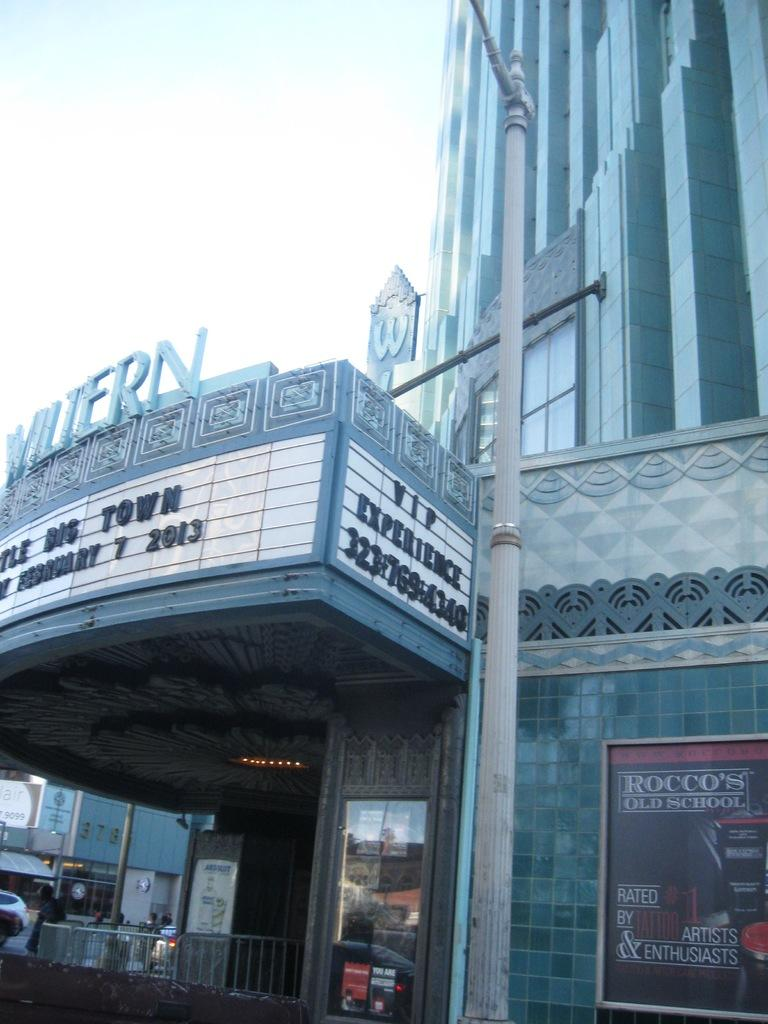What is the main structure in the image? There is a huge building in the image. What is located in front of the building? There is a pole in front of the building. What else can be seen in the image besides the building and pole? There are vehicles visible in the image. Where is the office located in the image? There is no specific mention of an office in the image, so it cannot be determined where it might be located. 